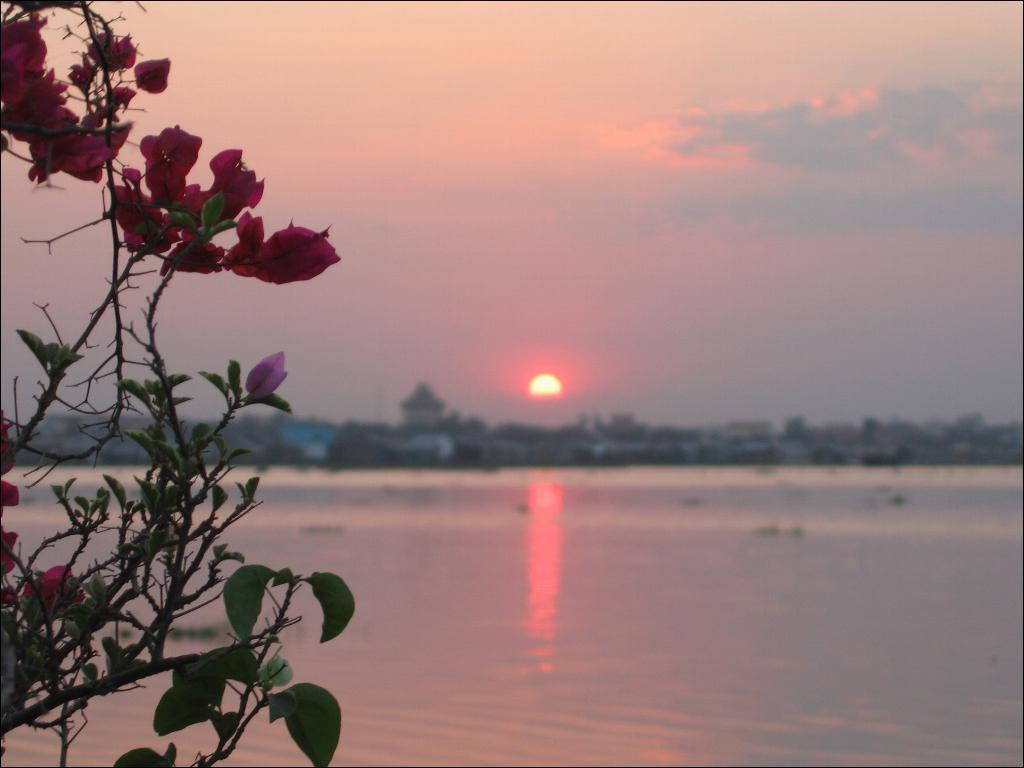What is the primary element visible in the image? There is a water surface in the image. What can be seen in the distance behind the water surface? There are buildings in the background of the image. What is visible above the water surface and buildings? The sky is visible in the image. Can you describe the celestial body in the sky? The sun is present in the sky. What type of vegetation is on the left side of the image? There are flower plants on the left side of the image. What type of volleyball court can be seen near the water surface in the image? There is no volleyball court present in the image. What time of day is it in the image, considering the presence of the sun? The presence of the sun does not necessarily indicate daytime; the sun could be setting, making it neither day nor night. 